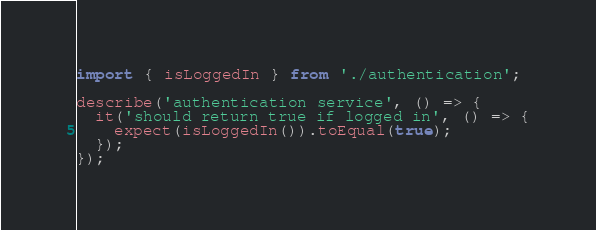Convert code to text. <code><loc_0><loc_0><loc_500><loc_500><_TypeScript_>import { isLoggedIn } from './authentication';

describe('authentication service', () => {
  it('should return true if logged in', () => {
    expect(isLoggedIn()).toEqual(true);
  });
});
</code> 